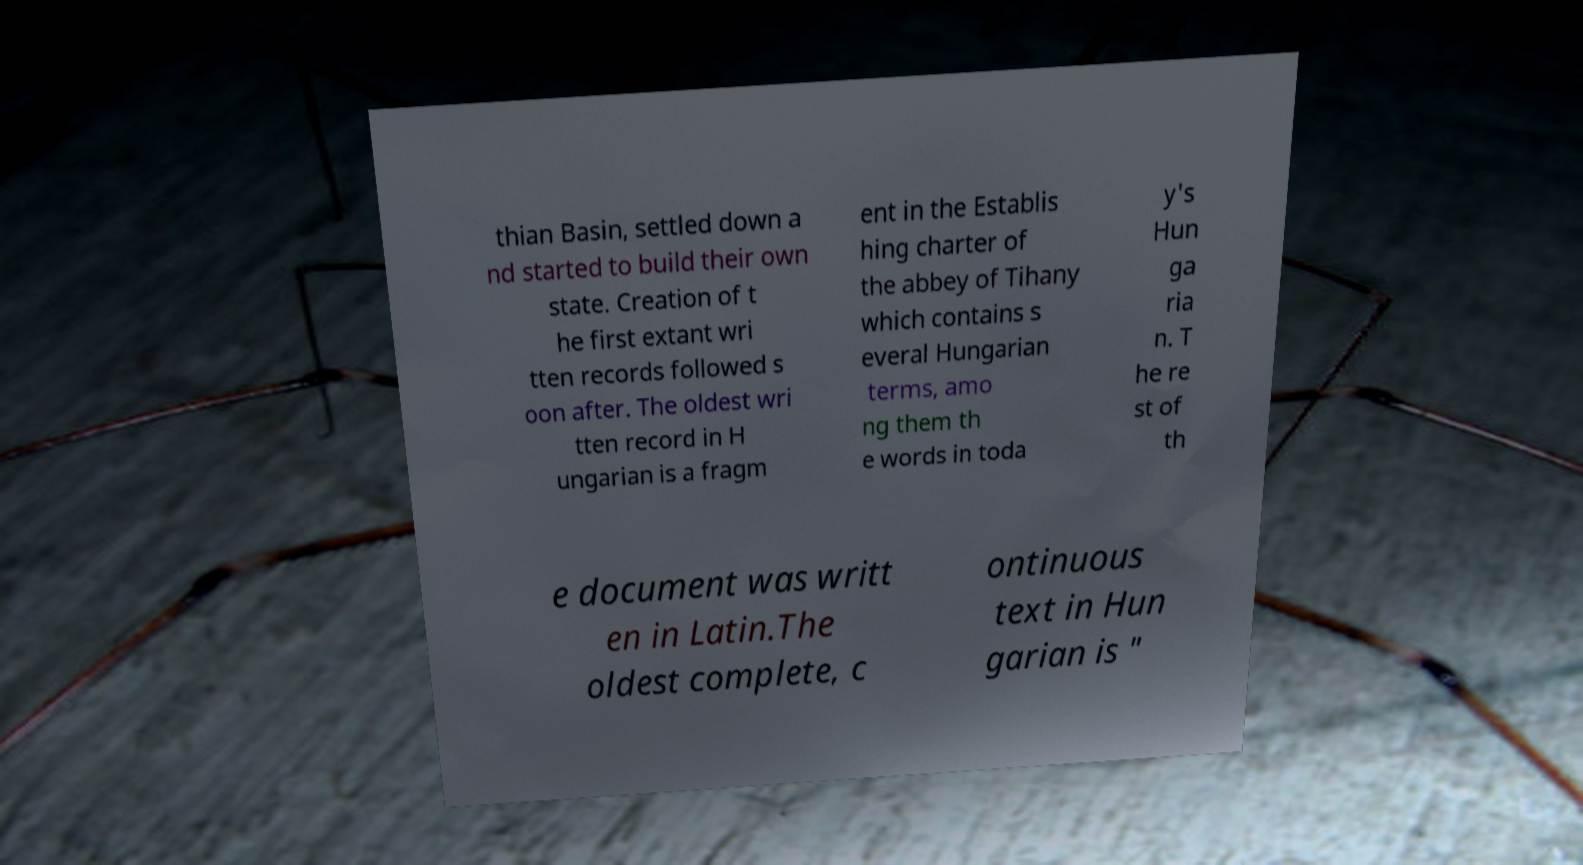Can you accurately transcribe the text from the provided image for me? thian Basin, settled down a nd started to build their own state. Creation of t he first extant wri tten records followed s oon after. The oldest wri tten record in H ungarian is a fragm ent in the Establis hing charter of the abbey of Tihany which contains s everal Hungarian terms, amo ng them th e words in toda y's Hun ga ria n. T he re st of th e document was writt en in Latin.The oldest complete, c ontinuous text in Hun garian is " 